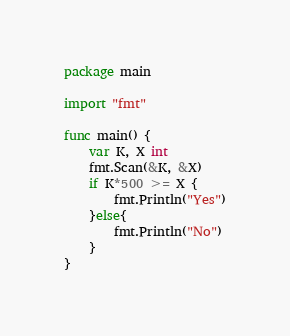<code> <loc_0><loc_0><loc_500><loc_500><_Go_>package main

import "fmt"

func main() {
	var K, X int
	fmt.Scan(&K, &X)
	if K*500 >= X {
		fmt.Println("Yes")
	}else{
		fmt.Println("No")
	}
}
</code> 